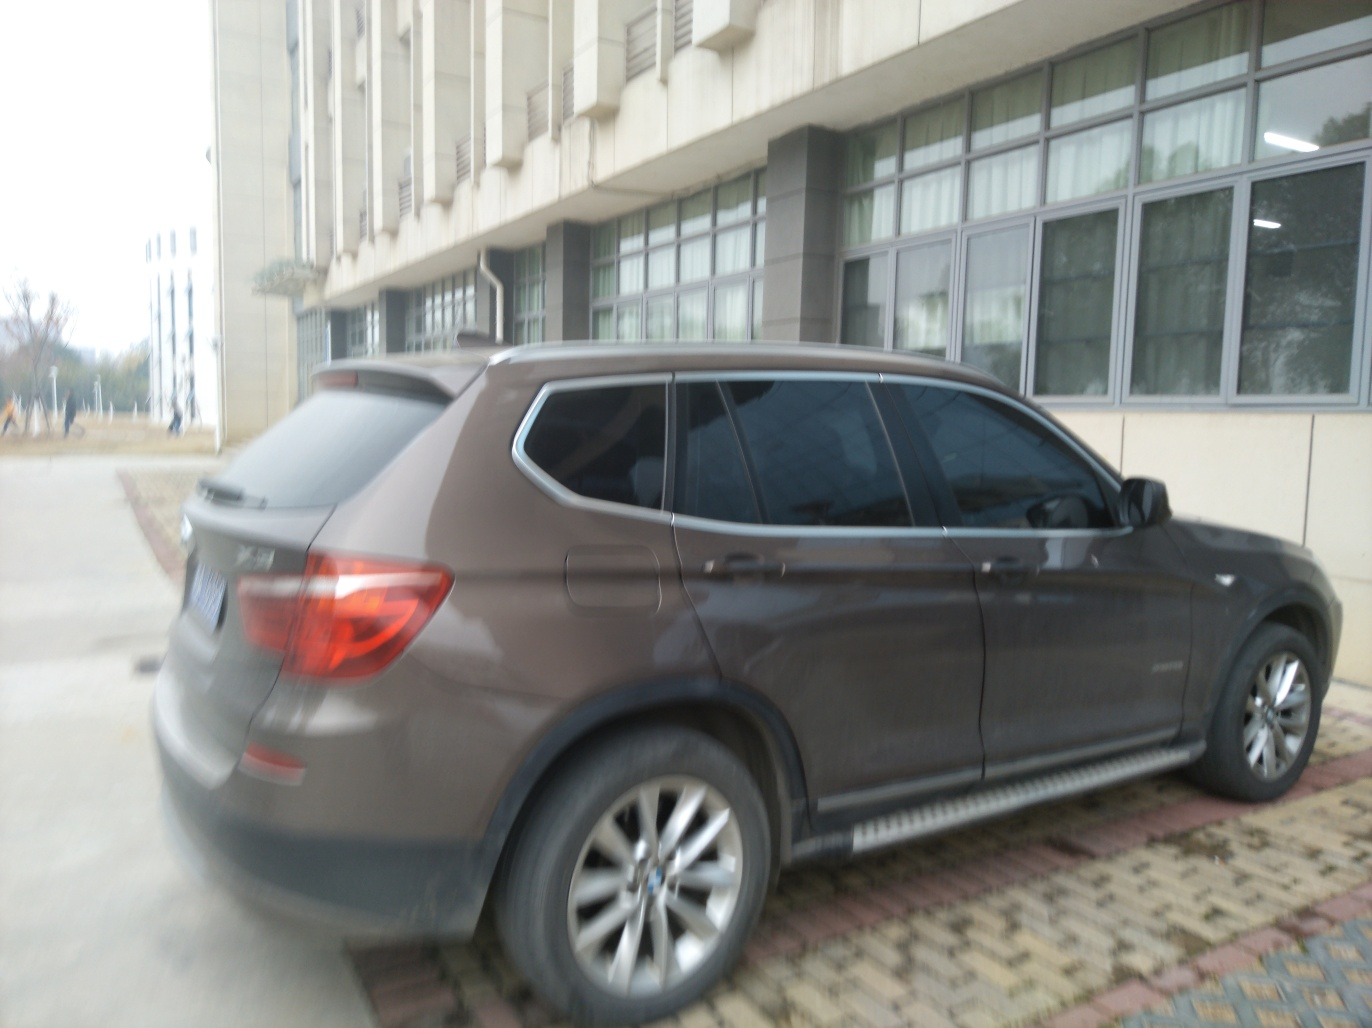Can you tell what time of day it might be based on the lighting in this image? The lighting in the image suggests it could be an overcast day or dusk given the absence of strong shadows and the overall subdued quality of light. However, without visible indicators like the position of the sun or the intensity of street lights, it's not possible to determine the time of day with certainty. Is there anything unusual or noteworthy about the car or its surroundings? The car appears to be a contemporary SUV, parked with its lights off. The surrounding area seems to be a quiet parking space outside a large building with many windows. Nothing particularly unusual stands out, though the slight blurriness of the image leaves room for finer details to go unnoticed. 